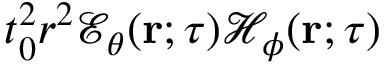Convert formula to latex. <formula><loc_0><loc_0><loc_500><loc_500>t _ { 0 } ^ { 2 } r ^ { 2 } { \mathcal { E } } _ { \theta } ( { r } ; \tau ) { \mathcal { H } } _ { \phi } ( { r } ; \tau )</formula> 